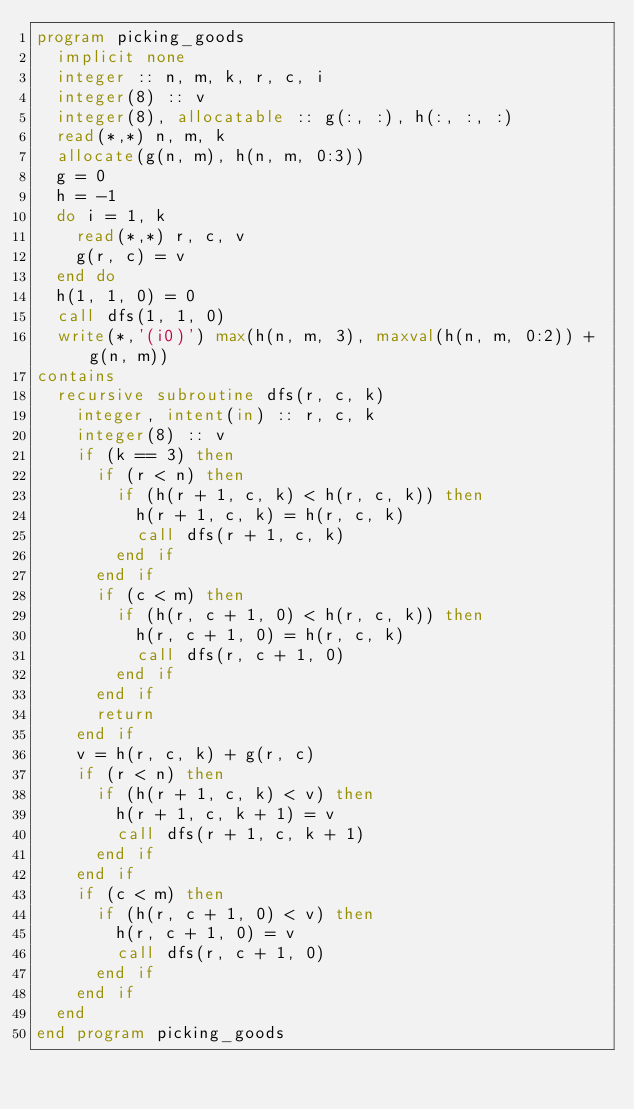<code> <loc_0><loc_0><loc_500><loc_500><_FORTRAN_>program picking_goods
  implicit none
  integer :: n, m, k, r, c, i
  integer(8) :: v
  integer(8), allocatable :: g(:, :), h(:, :, :)
  read(*,*) n, m, k
  allocate(g(n, m), h(n, m, 0:3))
  g = 0
  h = -1
  do i = 1, k
    read(*,*) r, c, v
    g(r, c) = v
  end do
  h(1, 1, 0) = 0
  call dfs(1, 1, 0)
  write(*,'(i0)') max(h(n, m, 3), maxval(h(n, m, 0:2)) + g(n, m))
contains
  recursive subroutine dfs(r, c, k)
    integer, intent(in) :: r, c, k
    integer(8) :: v
    if (k == 3) then
      if (r < n) then
        if (h(r + 1, c, k) < h(r, c, k)) then
          h(r + 1, c, k) = h(r, c, k)
          call dfs(r + 1, c, k)
        end if
      end if
      if (c < m) then
        if (h(r, c + 1, 0) < h(r, c, k)) then
          h(r, c + 1, 0) = h(r, c, k)
          call dfs(r, c + 1, 0)
        end if
      end if
      return
    end if
    v = h(r, c, k) + g(r, c)
    if (r < n) then
      if (h(r + 1, c, k) < v) then
        h(r + 1, c, k + 1) = v
        call dfs(r + 1, c, k + 1)
      end if
    end if
    if (c < m) then
      if (h(r, c + 1, 0) < v) then
        h(r, c + 1, 0) = v
        call dfs(r, c + 1, 0)
      end if
    end if
  end
end program picking_goods</code> 